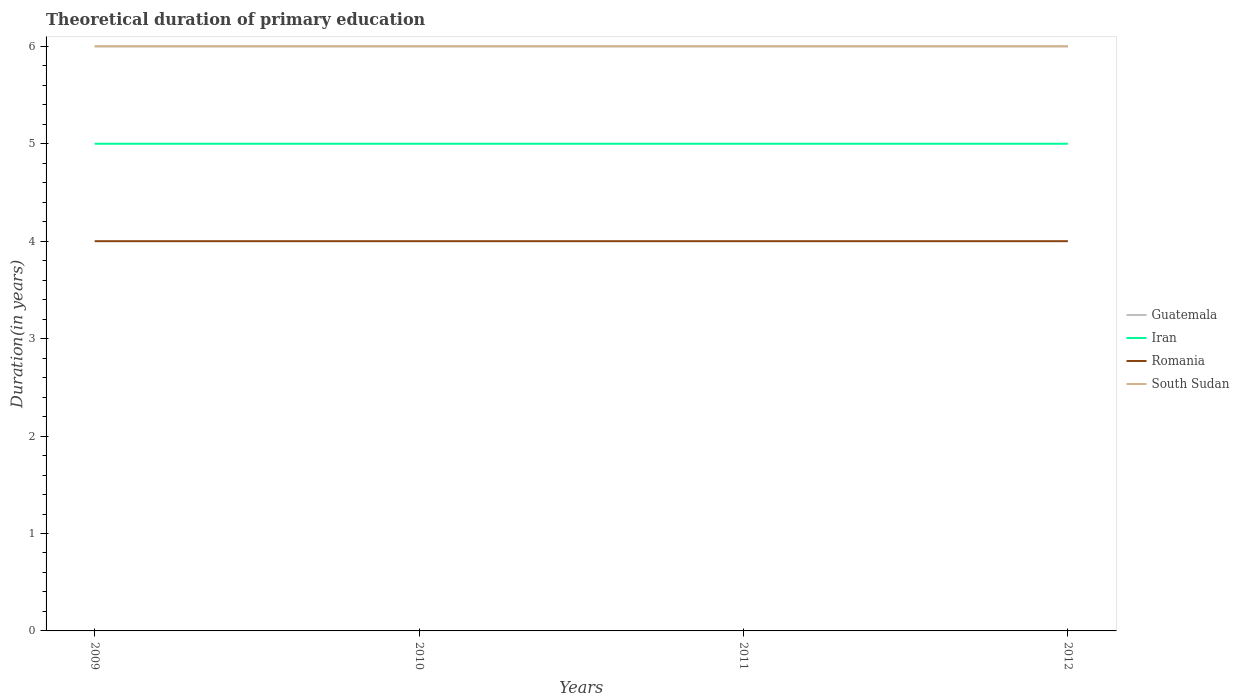Across all years, what is the maximum total theoretical duration of primary education in Guatemala?
Keep it short and to the point. 6. What is the total total theoretical duration of primary education in Guatemala in the graph?
Your answer should be compact. 0. What is the difference between the highest and the second highest total theoretical duration of primary education in South Sudan?
Your answer should be compact. 0. What is the difference between the highest and the lowest total theoretical duration of primary education in Guatemala?
Ensure brevity in your answer.  0. Is the total theoretical duration of primary education in Iran strictly greater than the total theoretical duration of primary education in Romania over the years?
Your response must be concise. No. How many lines are there?
Offer a very short reply. 4. What is the difference between two consecutive major ticks on the Y-axis?
Ensure brevity in your answer.  1. Does the graph contain grids?
Your response must be concise. No. Where does the legend appear in the graph?
Ensure brevity in your answer.  Center right. What is the title of the graph?
Keep it short and to the point. Theoretical duration of primary education. Does "Europe(all income levels)" appear as one of the legend labels in the graph?
Ensure brevity in your answer.  No. What is the label or title of the Y-axis?
Offer a very short reply. Duration(in years). What is the Duration(in years) of Guatemala in 2009?
Provide a succinct answer. 6. What is the Duration(in years) in Romania in 2009?
Make the answer very short. 4. What is the Duration(in years) in Guatemala in 2010?
Provide a short and direct response. 6. What is the Duration(in years) of Iran in 2010?
Provide a succinct answer. 5. What is the Duration(in years) of Romania in 2010?
Provide a short and direct response. 4. What is the Duration(in years) in South Sudan in 2010?
Keep it short and to the point. 6. What is the Duration(in years) in Guatemala in 2011?
Ensure brevity in your answer.  6. What is the Duration(in years) of South Sudan in 2012?
Your response must be concise. 6. Across all years, what is the maximum Duration(in years) in Guatemala?
Give a very brief answer. 6. Across all years, what is the maximum Duration(in years) in Iran?
Offer a terse response. 5. Across all years, what is the maximum Duration(in years) in South Sudan?
Offer a terse response. 6. Across all years, what is the minimum Duration(in years) of Guatemala?
Give a very brief answer. 6. Across all years, what is the minimum Duration(in years) of Iran?
Your response must be concise. 5. Across all years, what is the minimum Duration(in years) of Romania?
Your response must be concise. 4. What is the total Duration(in years) in Guatemala in the graph?
Provide a short and direct response. 24. What is the total Duration(in years) in Iran in the graph?
Offer a terse response. 20. What is the total Duration(in years) of Romania in the graph?
Give a very brief answer. 16. What is the difference between the Duration(in years) of Guatemala in 2009 and that in 2010?
Provide a succinct answer. 0. What is the difference between the Duration(in years) of Iran in 2009 and that in 2010?
Provide a succinct answer. 0. What is the difference between the Duration(in years) of South Sudan in 2009 and that in 2010?
Your answer should be compact. 0. What is the difference between the Duration(in years) in Guatemala in 2009 and that in 2011?
Provide a short and direct response. 0. What is the difference between the Duration(in years) in South Sudan in 2009 and that in 2011?
Your response must be concise. 0. What is the difference between the Duration(in years) of Romania in 2009 and that in 2012?
Offer a very short reply. 0. What is the difference between the Duration(in years) of South Sudan in 2009 and that in 2012?
Keep it short and to the point. 0. What is the difference between the Duration(in years) of Guatemala in 2010 and that in 2011?
Offer a very short reply. 0. What is the difference between the Duration(in years) in Iran in 2010 and that in 2011?
Ensure brevity in your answer.  0. What is the difference between the Duration(in years) in Romania in 2010 and that in 2011?
Your answer should be very brief. 0. What is the difference between the Duration(in years) in South Sudan in 2010 and that in 2011?
Your answer should be compact. 0. What is the difference between the Duration(in years) in Guatemala in 2010 and that in 2012?
Ensure brevity in your answer.  0. What is the difference between the Duration(in years) of Iran in 2010 and that in 2012?
Your answer should be very brief. 0. What is the difference between the Duration(in years) in Romania in 2010 and that in 2012?
Keep it short and to the point. 0. What is the difference between the Duration(in years) of South Sudan in 2010 and that in 2012?
Keep it short and to the point. 0. What is the difference between the Duration(in years) of Guatemala in 2011 and that in 2012?
Provide a succinct answer. 0. What is the difference between the Duration(in years) in Iran in 2011 and that in 2012?
Keep it short and to the point. 0. What is the difference between the Duration(in years) of South Sudan in 2011 and that in 2012?
Give a very brief answer. 0. What is the difference between the Duration(in years) of Guatemala in 2009 and the Duration(in years) of Romania in 2010?
Your answer should be compact. 2. What is the difference between the Duration(in years) in Guatemala in 2009 and the Duration(in years) in South Sudan in 2010?
Your answer should be compact. 0. What is the difference between the Duration(in years) in Romania in 2009 and the Duration(in years) in South Sudan in 2010?
Keep it short and to the point. -2. What is the difference between the Duration(in years) in Guatemala in 2009 and the Duration(in years) in Iran in 2011?
Offer a very short reply. 1. What is the difference between the Duration(in years) in Guatemala in 2009 and the Duration(in years) in Romania in 2011?
Offer a terse response. 2. What is the difference between the Duration(in years) in Guatemala in 2009 and the Duration(in years) in South Sudan in 2011?
Your answer should be very brief. 0. What is the difference between the Duration(in years) of Guatemala in 2009 and the Duration(in years) of South Sudan in 2012?
Your answer should be compact. 0. What is the difference between the Duration(in years) in Iran in 2009 and the Duration(in years) in Romania in 2012?
Ensure brevity in your answer.  1. What is the difference between the Duration(in years) in Iran in 2009 and the Duration(in years) in South Sudan in 2012?
Keep it short and to the point. -1. What is the difference between the Duration(in years) in Romania in 2009 and the Duration(in years) in South Sudan in 2012?
Your answer should be compact. -2. What is the difference between the Duration(in years) in Guatemala in 2010 and the Duration(in years) in Iran in 2011?
Provide a succinct answer. 1. What is the difference between the Duration(in years) of Guatemala in 2010 and the Duration(in years) of South Sudan in 2011?
Make the answer very short. 0. What is the difference between the Duration(in years) of Iran in 2010 and the Duration(in years) of Romania in 2011?
Provide a short and direct response. 1. What is the difference between the Duration(in years) of Iran in 2010 and the Duration(in years) of Romania in 2012?
Your answer should be compact. 1. What is the difference between the Duration(in years) in Guatemala in 2011 and the Duration(in years) in South Sudan in 2012?
Ensure brevity in your answer.  0. What is the difference between the Duration(in years) of Iran in 2011 and the Duration(in years) of South Sudan in 2012?
Provide a succinct answer. -1. What is the average Duration(in years) of Iran per year?
Keep it short and to the point. 5. What is the average Duration(in years) in Romania per year?
Offer a terse response. 4. In the year 2009, what is the difference between the Duration(in years) of Guatemala and Duration(in years) of Romania?
Offer a very short reply. 2. In the year 2009, what is the difference between the Duration(in years) of Guatemala and Duration(in years) of South Sudan?
Give a very brief answer. 0. In the year 2009, what is the difference between the Duration(in years) in Iran and Duration(in years) in Romania?
Your answer should be very brief. 1. In the year 2009, what is the difference between the Duration(in years) of Romania and Duration(in years) of South Sudan?
Make the answer very short. -2. In the year 2010, what is the difference between the Duration(in years) of Guatemala and Duration(in years) of Iran?
Make the answer very short. 1. In the year 2010, what is the difference between the Duration(in years) of Iran and Duration(in years) of Romania?
Your answer should be very brief. 1. In the year 2010, what is the difference between the Duration(in years) in Iran and Duration(in years) in South Sudan?
Your response must be concise. -1. In the year 2011, what is the difference between the Duration(in years) in Iran and Duration(in years) in Romania?
Offer a terse response. 1. In the year 2011, what is the difference between the Duration(in years) of Iran and Duration(in years) of South Sudan?
Make the answer very short. -1. In the year 2011, what is the difference between the Duration(in years) of Romania and Duration(in years) of South Sudan?
Your response must be concise. -2. In the year 2012, what is the difference between the Duration(in years) in Guatemala and Duration(in years) in South Sudan?
Keep it short and to the point. 0. What is the ratio of the Duration(in years) of Guatemala in 2009 to that in 2010?
Offer a very short reply. 1. What is the ratio of the Duration(in years) in Romania in 2009 to that in 2010?
Give a very brief answer. 1. What is the ratio of the Duration(in years) in South Sudan in 2009 to that in 2010?
Your answer should be very brief. 1. What is the ratio of the Duration(in years) in Guatemala in 2009 to that in 2011?
Offer a very short reply. 1. What is the ratio of the Duration(in years) in Iran in 2009 to that in 2011?
Offer a very short reply. 1. What is the ratio of the Duration(in years) of Romania in 2009 to that in 2011?
Your answer should be very brief. 1. What is the ratio of the Duration(in years) of Romania in 2009 to that in 2012?
Offer a very short reply. 1. What is the ratio of the Duration(in years) in South Sudan in 2009 to that in 2012?
Give a very brief answer. 1. What is the ratio of the Duration(in years) of South Sudan in 2010 to that in 2011?
Keep it short and to the point. 1. What is the ratio of the Duration(in years) of Guatemala in 2010 to that in 2012?
Your response must be concise. 1. What is the ratio of the Duration(in years) of Iran in 2010 to that in 2012?
Ensure brevity in your answer.  1. What is the ratio of the Duration(in years) in Guatemala in 2011 to that in 2012?
Provide a short and direct response. 1. What is the ratio of the Duration(in years) of Iran in 2011 to that in 2012?
Make the answer very short. 1. What is the ratio of the Duration(in years) of Romania in 2011 to that in 2012?
Your response must be concise. 1. What is the ratio of the Duration(in years) in South Sudan in 2011 to that in 2012?
Offer a very short reply. 1. What is the difference between the highest and the second highest Duration(in years) of Guatemala?
Offer a very short reply. 0. What is the difference between the highest and the second highest Duration(in years) in Romania?
Make the answer very short. 0. What is the difference between the highest and the lowest Duration(in years) in Iran?
Provide a short and direct response. 0. What is the difference between the highest and the lowest Duration(in years) in South Sudan?
Give a very brief answer. 0. 